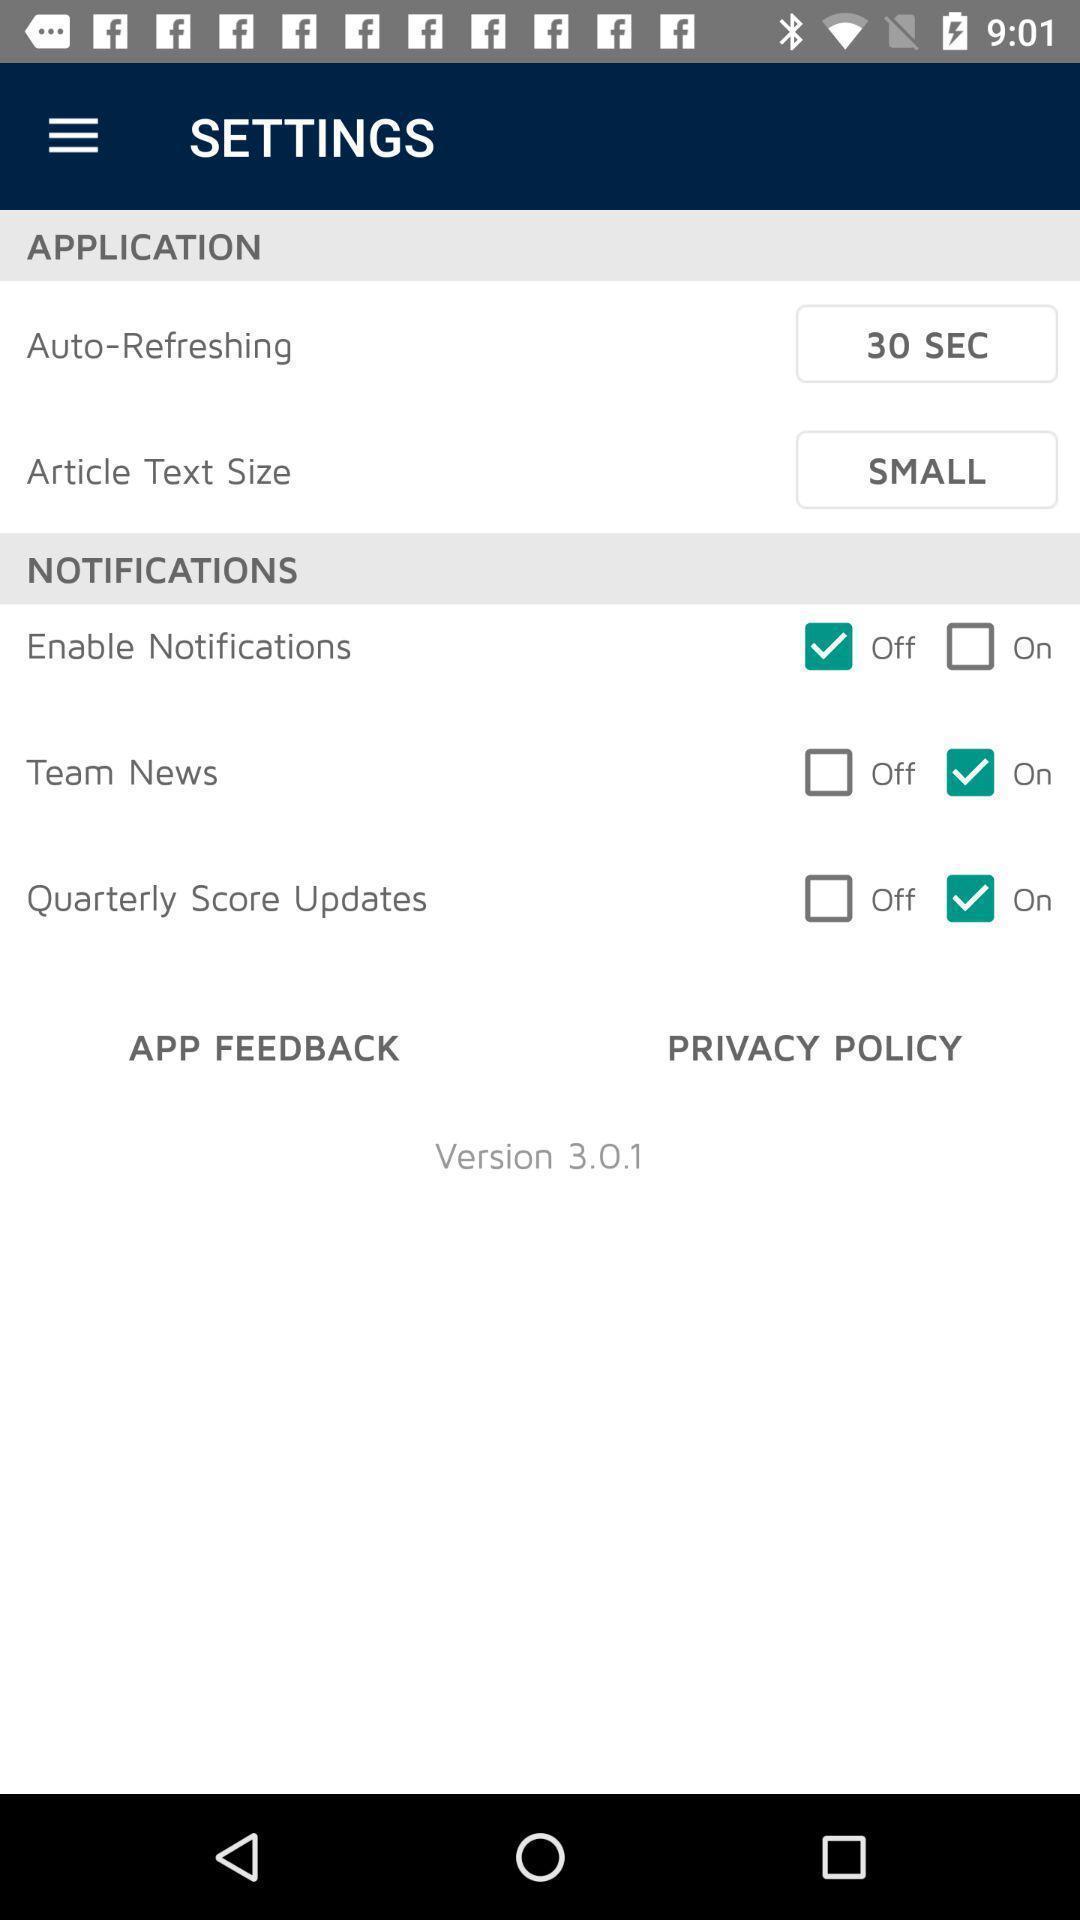Summarize the information in this screenshot. Settings page. 